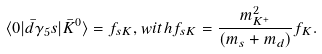<formula> <loc_0><loc_0><loc_500><loc_500>\langle 0 | \bar { d } \gamma _ { 5 } s | \bar { K } ^ { 0 } \rangle = f _ { s K } , w i t h f _ { s K } = \frac { m ^ { 2 } _ { K ^ { + } } } { ( m _ { s } + m _ { d } ) } f _ { K } .</formula> 